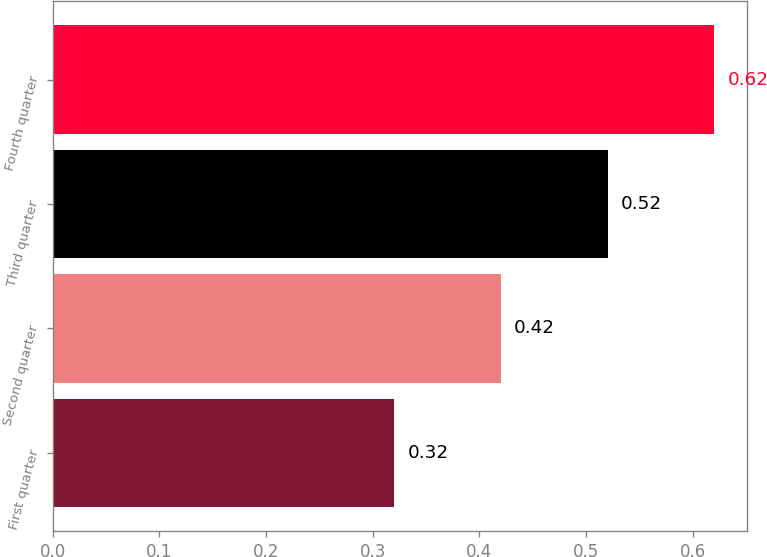<chart> <loc_0><loc_0><loc_500><loc_500><bar_chart><fcel>First quarter<fcel>Second quarter<fcel>Third quarter<fcel>Fourth quarter<nl><fcel>0.32<fcel>0.42<fcel>0.52<fcel>0.62<nl></chart> 